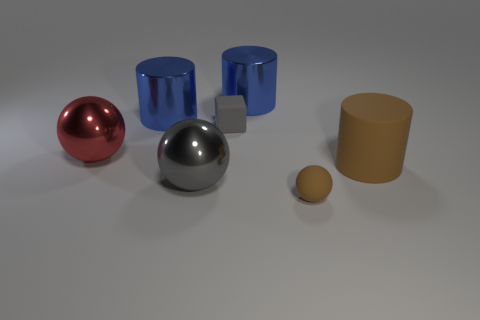Add 2 metal things. How many objects exist? 9 Subtract all balls. How many objects are left? 4 Subtract 1 blue cylinders. How many objects are left? 6 Subtract all tiny blue matte cylinders. Subtract all gray metallic balls. How many objects are left? 6 Add 2 large matte objects. How many large matte objects are left? 3 Add 7 gray blocks. How many gray blocks exist? 8 